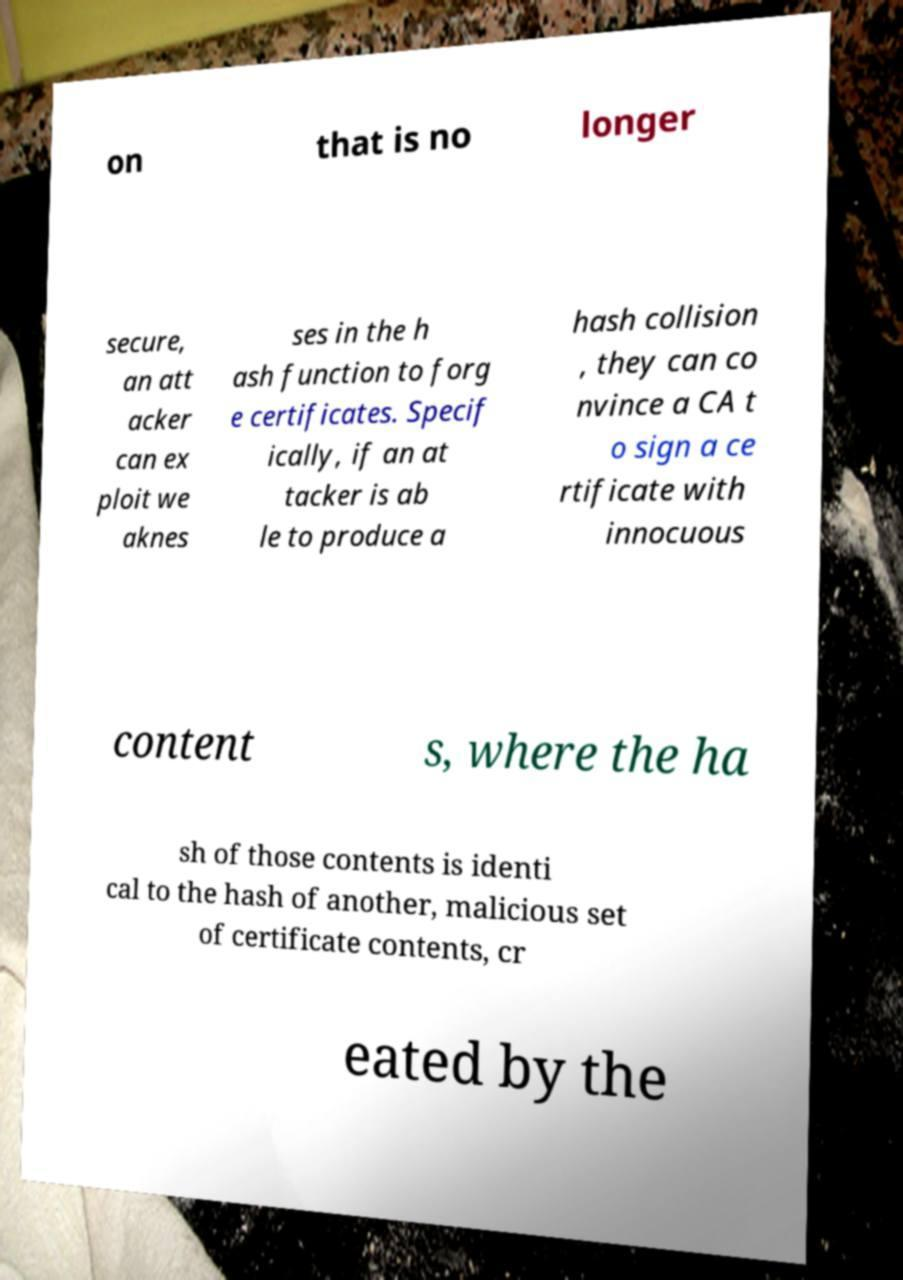There's text embedded in this image that I need extracted. Can you transcribe it verbatim? on that is no longer secure, an att acker can ex ploit we aknes ses in the h ash function to forg e certificates. Specif ically, if an at tacker is ab le to produce a hash collision , they can co nvince a CA t o sign a ce rtificate with innocuous content s, where the ha sh of those contents is identi cal to the hash of another, malicious set of certificate contents, cr eated by the 